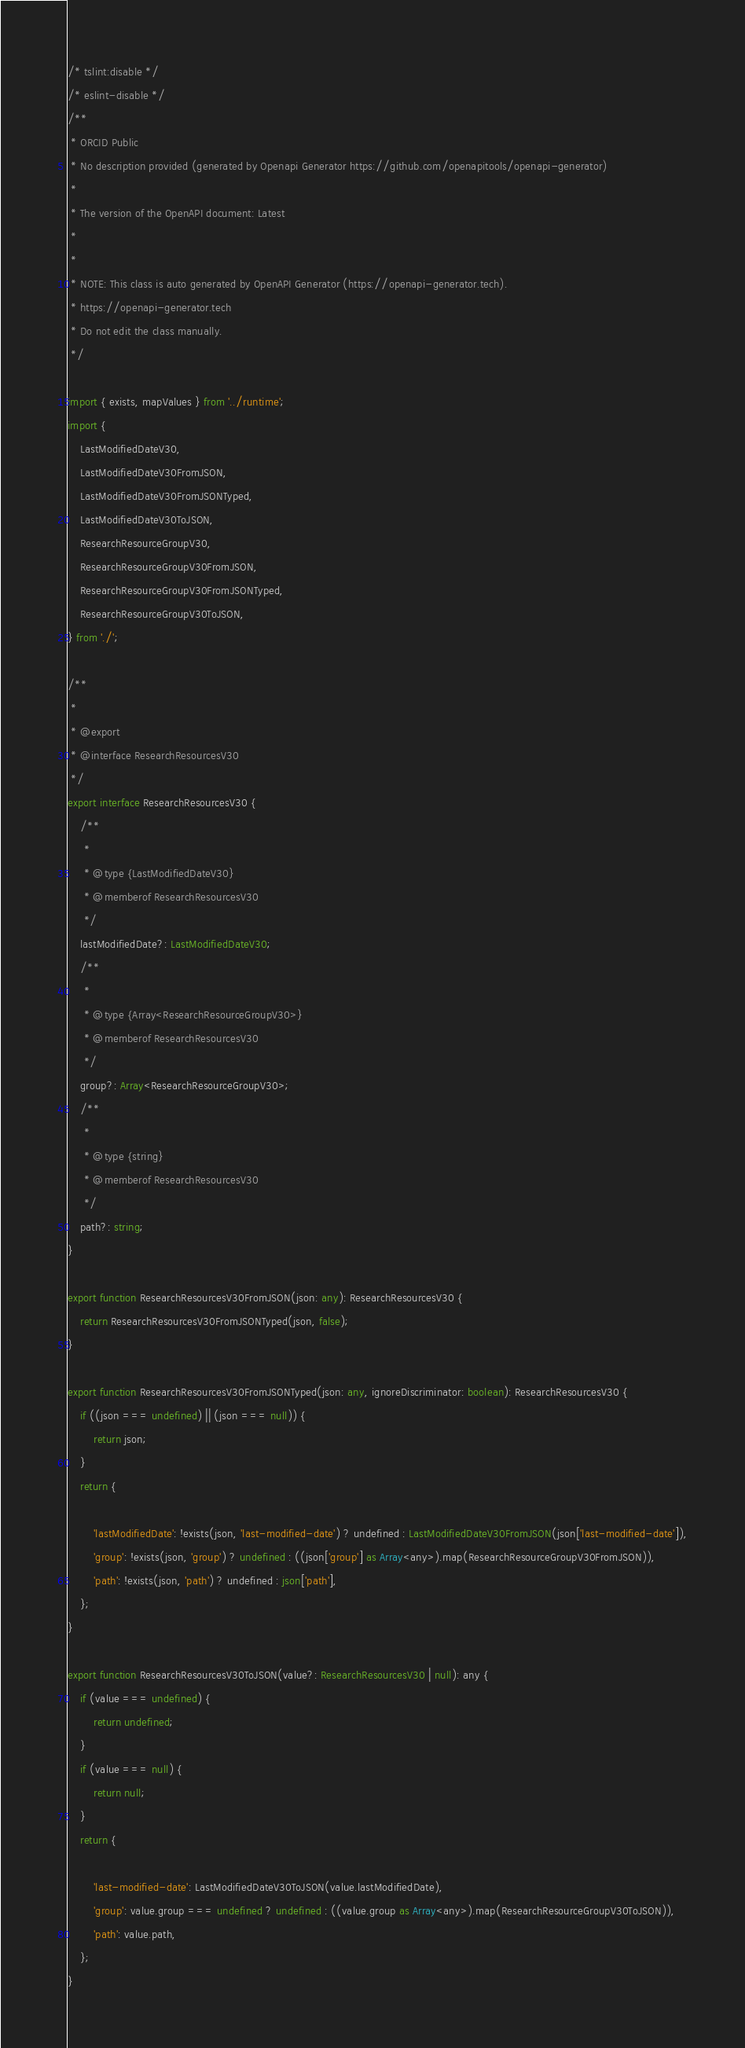<code> <loc_0><loc_0><loc_500><loc_500><_TypeScript_>/* tslint:disable */
/* eslint-disable */
/**
 * ORCID Public
 * No description provided (generated by Openapi Generator https://github.com/openapitools/openapi-generator)
 *
 * The version of the OpenAPI document: Latest
 * 
 *
 * NOTE: This class is auto generated by OpenAPI Generator (https://openapi-generator.tech).
 * https://openapi-generator.tech
 * Do not edit the class manually.
 */

import { exists, mapValues } from '../runtime';
import {
    LastModifiedDateV30,
    LastModifiedDateV30FromJSON,
    LastModifiedDateV30FromJSONTyped,
    LastModifiedDateV30ToJSON,
    ResearchResourceGroupV30,
    ResearchResourceGroupV30FromJSON,
    ResearchResourceGroupV30FromJSONTyped,
    ResearchResourceGroupV30ToJSON,
} from './';

/**
 * 
 * @export
 * @interface ResearchResourcesV30
 */
export interface ResearchResourcesV30 {
    /**
     * 
     * @type {LastModifiedDateV30}
     * @memberof ResearchResourcesV30
     */
    lastModifiedDate?: LastModifiedDateV30;
    /**
     * 
     * @type {Array<ResearchResourceGroupV30>}
     * @memberof ResearchResourcesV30
     */
    group?: Array<ResearchResourceGroupV30>;
    /**
     * 
     * @type {string}
     * @memberof ResearchResourcesV30
     */
    path?: string;
}

export function ResearchResourcesV30FromJSON(json: any): ResearchResourcesV30 {
    return ResearchResourcesV30FromJSONTyped(json, false);
}

export function ResearchResourcesV30FromJSONTyped(json: any, ignoreDiscriminator: boolean): ResearchResourcesV30 {
    if ((json === undefined) || (json === null)) {
        return json;
    }
    return {
        
        'lastModifiedDate': !exists(json, 'last-modified-date') ? undefined : LastModifiedDateV30FromJSON(json['last-modified-date']),
        'group': !exists(json, 'group') ? undefined : ((json['group'] as Array<any>).map(ResearchResourceGroupV30FromJSON)),
        'path': !exists(json, 'path') ? undefined : json['path'],
    };
}

export function ResearchResourcesV30ToJSON(value?: ResearchResourcesV30 | null): any {
    if (value === undefined) {
        return undefined;
    }
    if (value === null) {
        return null;
    }
    return {
        
        'last-modified-date': LastModifiedDateV30ToJSON(value.lastModifiedDate),
        'group': value.group === undefined ? undefined : ((value.group as Array<any>).map(ResearchResourceGroupV30ToJSON)),
        'path': value.path,
    };
}


</code> 